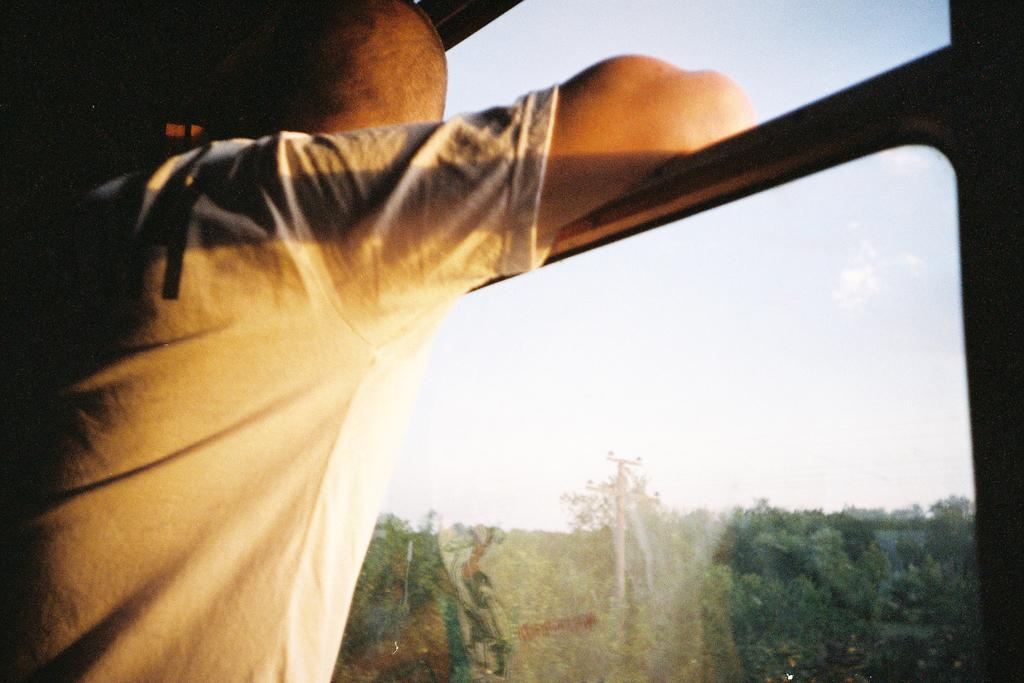What is the main subject of the image? There is a person in the image. What is the person wearing? The person is wearing a T-shirt. Where is the person standing in relation to the windows? The person is standing near glass windows. What can be seen through the windows? Current poles, trees, and the sky are visible through the windows. What type of clock is hanging on the curve of the current pole in the image? There is no clock visible in the image, nor is there any mention of a curve on the current pole. 